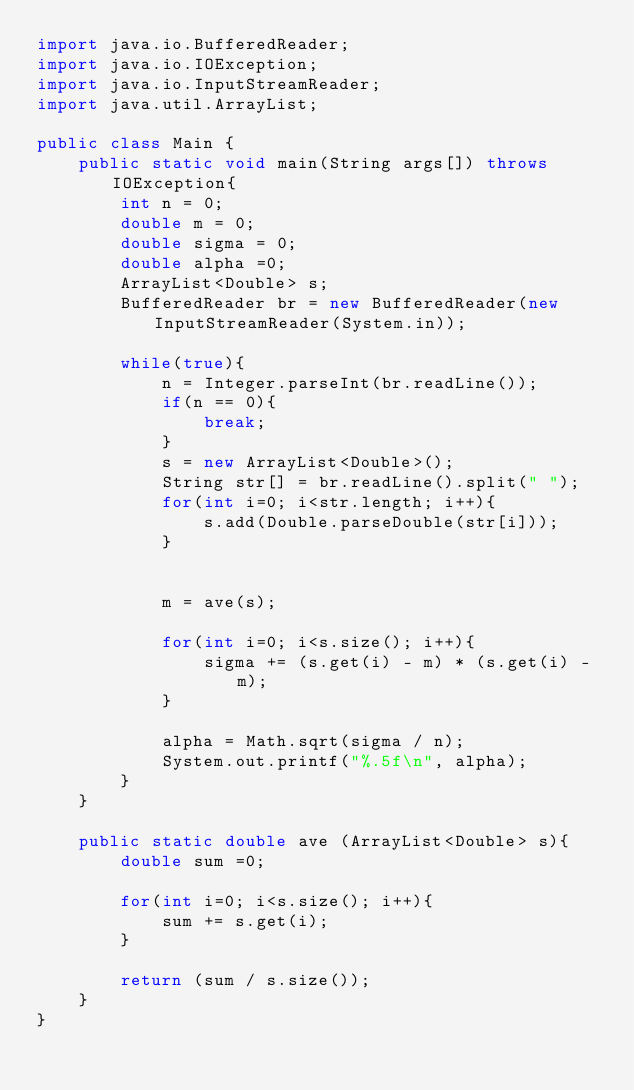Convert code to text. <code><loc_0><loc_0><loc_500><loc_500><_Java_>import java.io.BufferedReader;
import java.io.IOException;
import java.io.InputStreamReader;
import java.util.ArrayList;

public class Main {
	public static void main(String args[]) throws IOException{
		int n = 0;
		double m = 0;
		double sigma = 0;
		double alpha =0;
		ArrayList<Double> s;
		BufferedReader br = new BufferedReader(new InputStreamReader(System.in));
		
		while(true){
			n = Integer.parseInt(br.readLine());
			if(n == 0){
				break;
			}
			s = new ArrayList<Double>();
			String str[] = br.readLine().split(" ");
			for(int i=0; i<str.length; i++){
				s.add(Double.parseDouble(str[i]));
			}
			
			
			m = ave(s);
			
			for(int i=0; i<s.size(); i++){
				sigma += (s.get(i) - m) * (s.get(i) - m);
			}
			
			alpha = Math.sqrt(sigma / n);
			System.out.printf("%.5f\n", alpha);
		}
	}
	
	public static double ave (ArrayList<Double> s){
		double sum =0;
		
		for(int i=0; i<s.size(); i++){
			sum += s.get(i);
		}
		
		return (sum / s.size());
	}
}</code> 